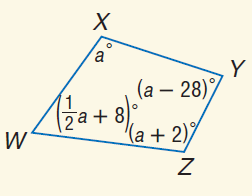Answer the mathemtical geometry problem and directly provide the correct option letter.
Question: Find m \angle X.
Choices: A: 62 B: 80 C: 108 D: 110 C 